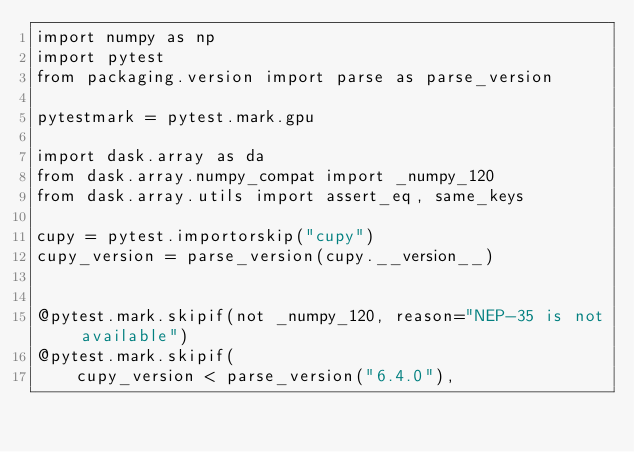Convert code to text. <code><loc_0><loc_0><loc_500><loc_500><_Python_>import numpy as np
import pytest
from packaging.version import parse as parse_version

pytestmark = pytest.mark.gpu

import dask.array as da
from dask.array.numpy_compat import _numpy_120
from dask.array.utils import assert_eq, same_keys

cupy = pytest.importorskip("cupy")
cupy_version = parse_version(cupy.__version__)


@pytest.mark.skipif(not _numpy_120, reason="NEP-35 is not available")
@pytest.mark.skipif(
    cupy_version < parse_version("6.4.0"),</code> 